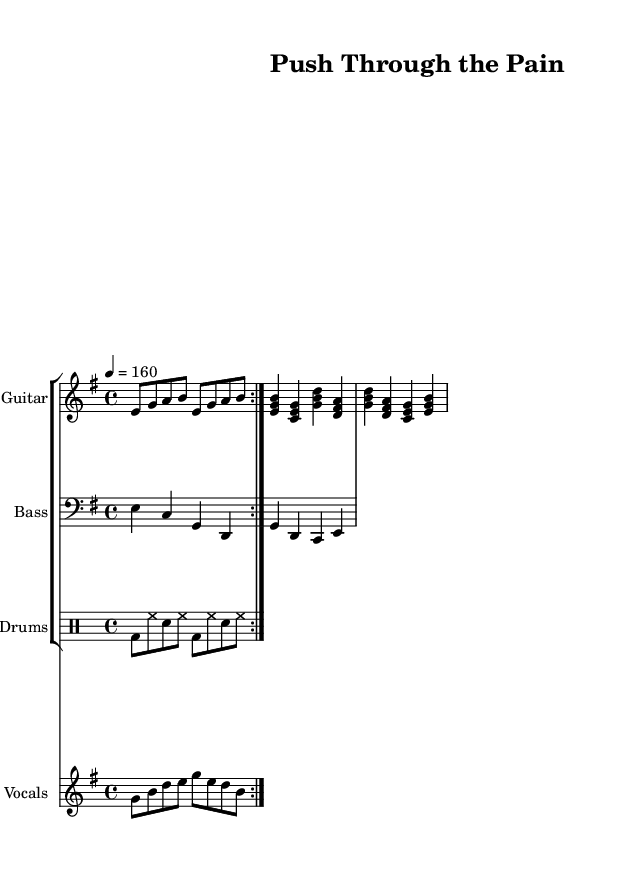What is the key signature of this music? The key signature is E minor, indicated by the one sharp (F#) in the key signature section. E minor is the relative minor of G major.
Answer: E minor What is the time signature of this piece? The time signature is 4/4, shown at the start of the sheet music. This means there are four beats in each measure, and the quarter note gets one beat.
Answer: 4/4 What is the tempo marking for the music? The tempo marking indicates a speed of 160 beats per minute, noted as "4 = 160" at the beginning. This gives the performer a clear understanding of how fast to play.
Answer: 160 How many measures are in the guitar verse? The guitar verse consists of four measures, as indicated by the notation that shows the grouped notes in sets of four beats within the 4/4 time signature.
Answer: 4 What rhythmic pattern do the drums play during the verse? The drums play a steady pattern of bass drum, hi-hat, snare, hi-hat repeated twice, which establishes a consistent rhythmic foundation for the rest of the band.
Answer: Bass, hi-hat, snare How does the melody of the vocals start? The melody begins on the note G, starting with a sequence of notes (G, B, D, E) that create a rising motion, which matches the motivational theme of the lyrics "Push through the pain."
Answer: G What is the lyrical theme of this song? The lyrics focus on resilience and strength in the face of challenges, encouraging listeners to push through hardships and rise up, which aligns with the high-energy rock genre.
Answer: Overcoming challenges 